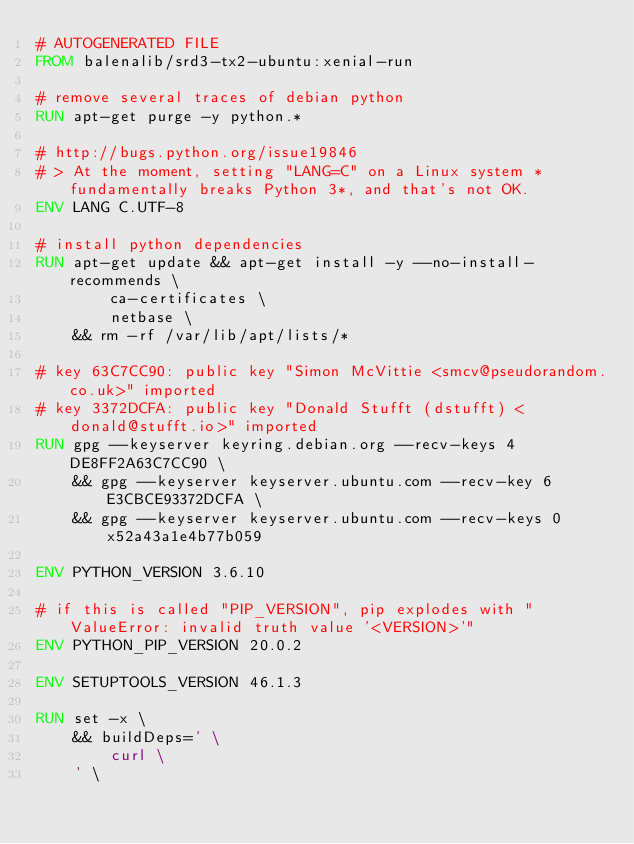Convert code to text. <code><loc_0><loc_0><loc_500><loc_500><_Dockerfile_># AUTOGENERATED FILE
FROM balenalib/srd3-tx2-ubuntu:xenial-run

# remove several traces of debian python
RUN apt-get purge -y python.*

# http://bugs.python.org/issue19846
# > At the moment, setting "LANG=C" on a Linux system *fundamentally breaks Python 3*, and that's not OK.
ENV LANG C.UTF-8

# install python dependencies
RUN apt-get update && apt-get install -y --no-install-recommends \
		ca-certificates \
		netbase \
	&& rm -rf /var/lib/apt/lists/*

# key 63C7CC90: public key "Simon McVittie <smcv@pseudorandom.co.uk>" imported
# key 3372DCFA: public key "Donald Stufft (dstufft) <donald@stufft.io>" imported
RUN gpg --keyserver keyring.debian.org --recv-keys 4DE8FF2A63C7CC90 \
	&& gpg --keyserver keyserver.ubuntu.com --recv-key 6E3CBCE93372DCFA \
	&& gpg --keyserver keyserver.ubuntu.com --recv-keys 0x52a43a1e4b77b059

ENV PYTHON_VERSION 3.6.10

# if this is called "PIP_VERSION", pip explodes with "ValueError: invalid truth value '<VERSION>'"
ENV PYTHON_PIP_VERSION 20.0.2

ENV SETUPTOOLS_VERSION 46.1.3

RUN set -x \
	&& buildDeps=' \
		curl \
	' \</code> 